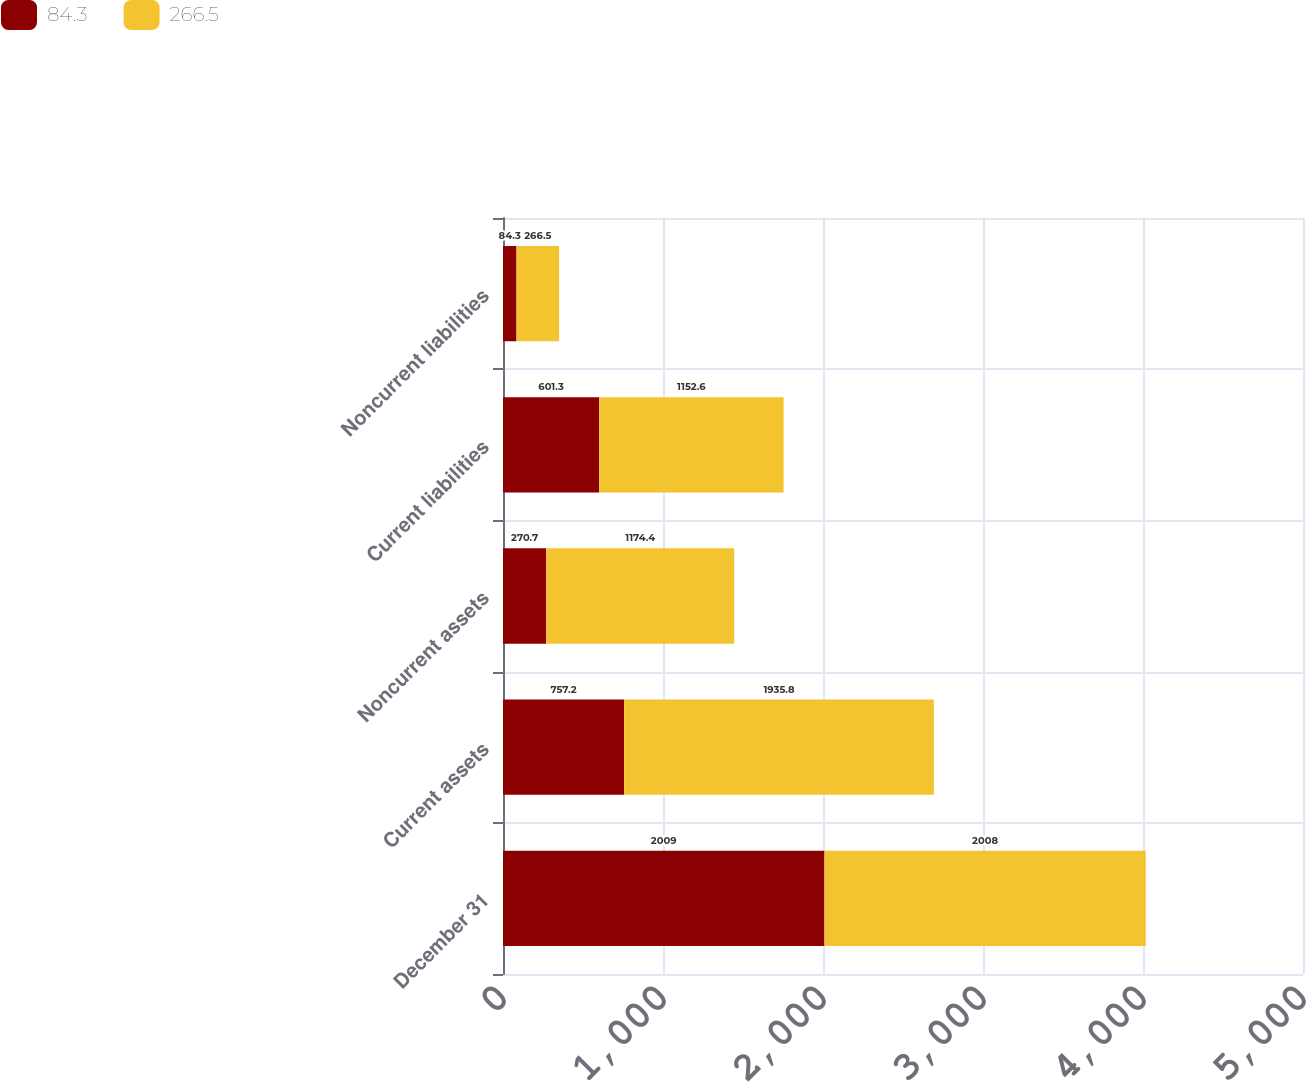Convert chart. <chart><loc_0><loc_0><loc_500><loc_500><stacked_bar_chart><ecel><fcel>December 31<fcel>Current assets<fcel>Noncurrent assets<fcel>Current liabilities<fcel>Noncurrent liabilities<nl><fcel>84.3<fcel>2009<fcel>757.2<fcel>270.7<fcel>601.3<fcel>84.3<nl><fcel>266.5<fcel>2008<fcel>1935.8<fcel>1174.4<fcel>1152.6<fcel>266.5<nl></chart> 